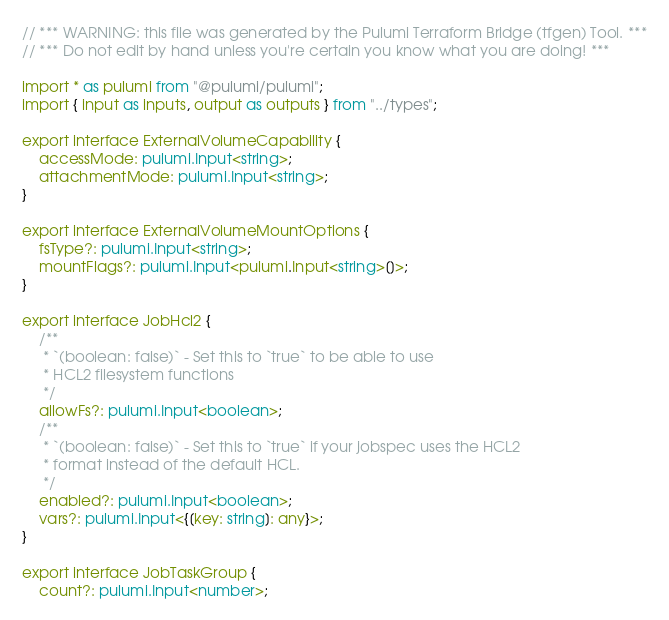Convert code to text. <code><loc_0><loc_0><loc_500><loc_500><_TypeScript_>// *** WARNING: this file was generated by the Pulumi Terraform Bridge (tfgen) Tool. ***
// *** Do not edit by hand unless you're certain you know what you are doing! ***

import * as pulumi from "@pulumi/pulumi";
import { input as inputs, output as outputs } from "../types";

export interface ExternalVolumeCapability {
    accessMode: pulumi.Input<string>;
    attachmentMode: pulumi.Input<string>;
}

export interface ExternalVolumeMountOptions {
    fsType?: pulumi.Input<string>;
    mountFlags?: pulumi.Input<pulumi.Input<string>[]>;
}

export interface JobHcl2 {
    /**
     * `(boolean: false)` - Set this to `true` to be able to use
     * HCL2 filesystem functions
     */
    allowFs?: pulumi.Input<boolean>;
    /**
     * `(boolean: false)` - Set this to `true` if your jobspec uses the HCL2
     * format instead of the default HCL.
     */
    enabled?: pulumi.Input<boolean>;
    vars?: pulumi.Input<{[key: string]: any}>;
}

export interface JobTaskGroup {
    count?: pulumi.Input<number>;</code> 